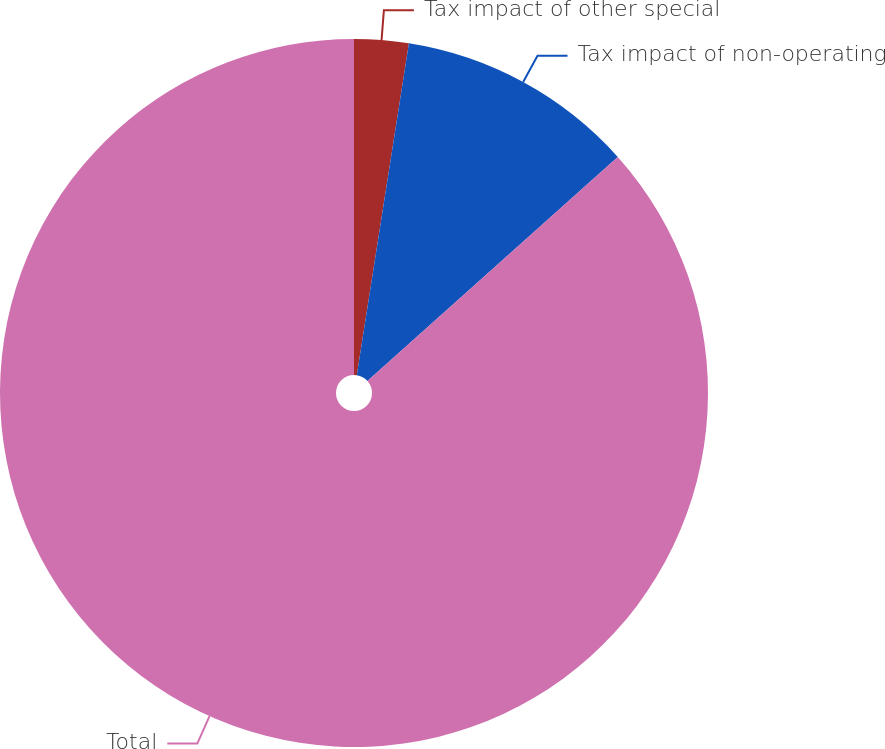<chart> <loc_0><loc_0><loc_500><loc_500><pie_chart><fcel>Tax impact of other special<fcel>Tax impact of non-operating<fcel>Total<nl><fcel>2.48%<fcel>10.9%<fcel>86.62%<nl></chart> 